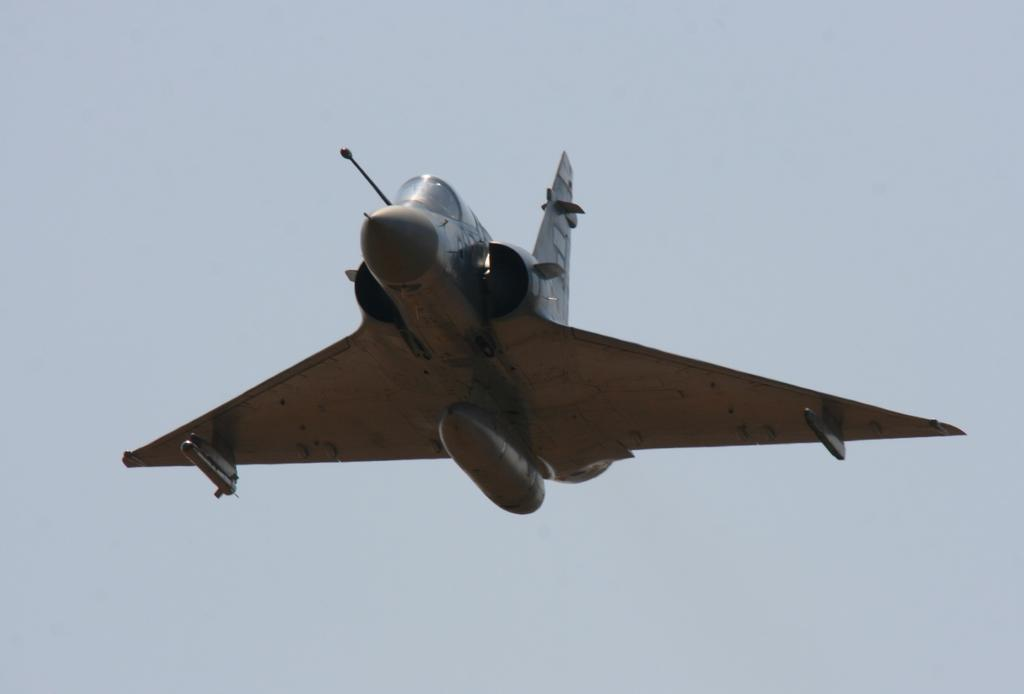What is the main subject of the image? The main subject of the image is an aircraft. Can you describe the position of the aircraft in the image? The aircraft is in the air in the image. What can be seen in the background of the image? The sky is visible in the background of the image. What type of bomb can be seen falling from the aircraft in the image? There is no bomb visible in the image; the image only shows an aircraft in the air. Can you describe the material of the marble that is present in the image? There is no marble present in the image; it only features an aircraft in the air. 